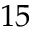Convert formula to latex. <formula><loc_0><loc_0><loc_500><loc_500>1 5</formula> 